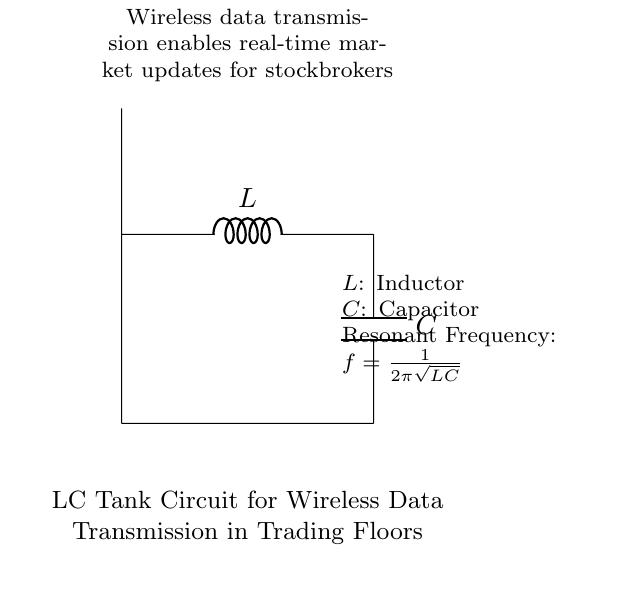What components are present in this circuit? The circuit contains an inductor and a capacitor, which are the primary components labeled L and C respectively.
Answer: Inductor and Capacitor What does the circuit diagram represent? This circuit diagram depicts an LC tank circuit designed for wireless data transmission, as stated in the descriptor below the components.
Answer: LC tank circuit for wireless data transmission What is the resonant frequency formula in this circuit? The resonant frequency is given by the formula f equals one over two pi times the square root of LC. This relates the frequency of oscillation to the values of both the inductor and capacitor.
Answer: f equals one over two pi square root LC Which component is responsible for storing energy in the electric field? The capacitor is the component responsible for storing energy in the electric field when it is charged. It interacts with the inductor in this LC circuit to create oscillations.
Answer: Capacitor How does the circuit enable real-time market updates? The LC tank circuit facilitates wireless data transmission, which allows stockbrokers to receive real-time market updates as it can resonate at specific frequencies suited for communication.
Answer: Wireless data transmission What happens when the resonance condition is met in this circuit? When the resonance condition is met, the circuit can oscillate at a specific frequency, maximizing the energy transfer between the inductor and capacitor, thus enhancing the signal for data transmission.
Answer: Maximized energy transfer What role does the inductor play in this circuit? The inductor stores energy in a magnetic field and is essential for creating oscillations in conjunction with the capacitor, forming the basis of the LC tank circuit operation.
Answer: Stores energy in a magnetic field 